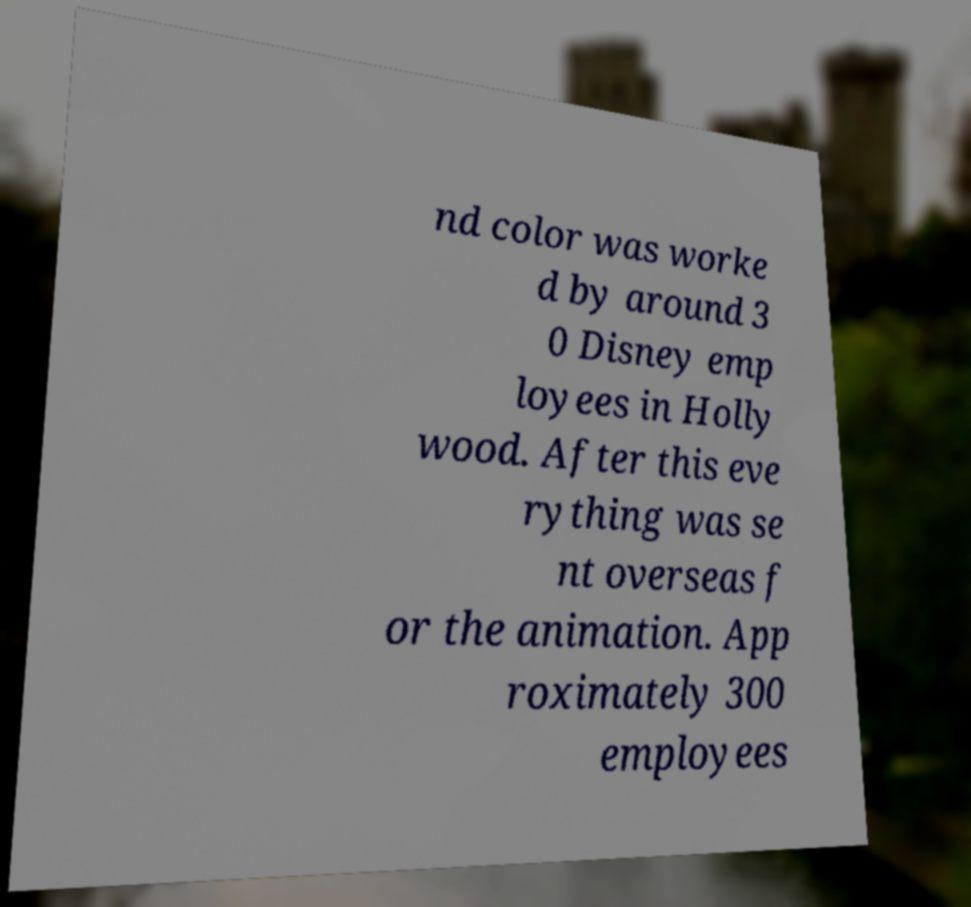For documentation purposes, I need the text within this image transcribed. Could you provide that? nd color was worke d by around 3 0 Disney emp loyees in Holly wood. After this eve rything was se nt overseas f or the animation. App roximately 300 employees 